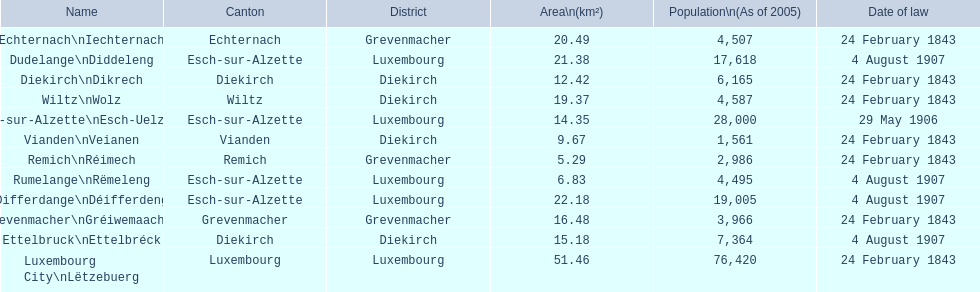How many luxembourg cities had a date of law of feb 24, 1843? 7. 